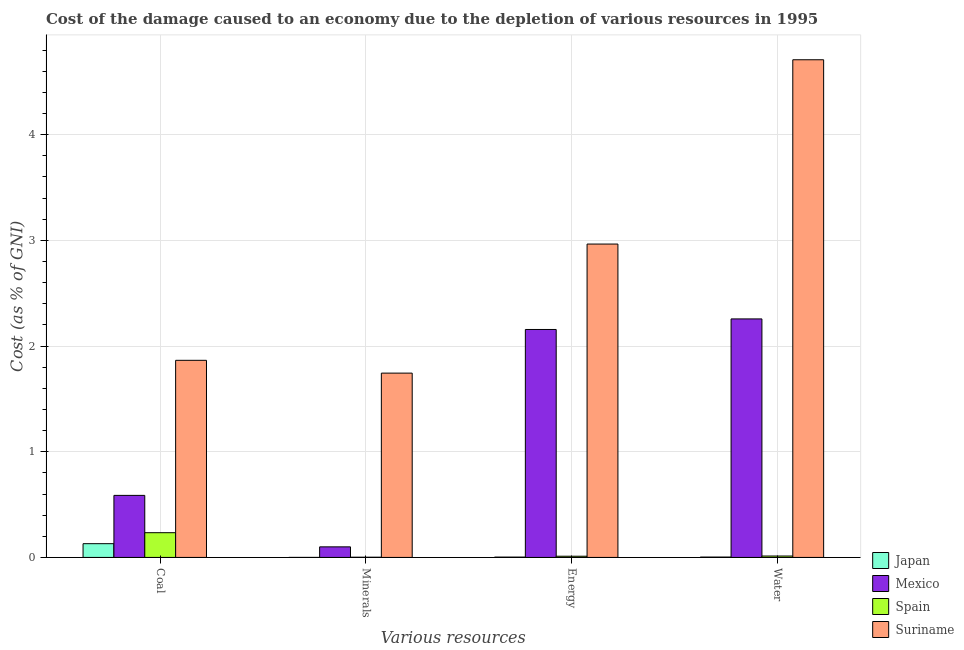How many bars are there on the 4th tick from the left?
Give a very brief answer. 4. What is the label of the 4th group of bars from the left?
Your response must be concise. Water. What is the cost of damage due to depletion of water in Suriname?
Offer a very short reply. 4.71. Across all countries, what is the maximum cost of damage due to depletion of water?
Your answer should be compact. 4.71. Across all countries, what is the minimum cost of damage due to depletion of water?
Offer a terse response. 0. In which country was the cost of damage due to depletion of coal maximum?
Your answer should be very brief. Suriname. In which country was the cost of damage due to depletion of coal minimum?
Keep it short and to the point. Japan. What is the total cost of damage due to depletion of coal in the graph?
Your response must be concise. 2.82. What is the difference between the cost of damage due to depletion of water in Suriname and that in Japan?
Your answer should be very brief. 4.71. What is the difference between the cost of damage due to depletion of water in Japan and the cost of damage due to depletion of minerals in Mexico?
Make the answer very short. -0.1. What is the average cost of damage due to depletion of energy per country?
Provide a short and direct response. 1.28. What is the difference between the cost of damage due to depletion of coal and cost of damage due to depletion of water in Suriname?
Keep it short and to the point. -2.84. In how many countries, is the cost of damage due to depletion of water greater than 0.2 %?
Offer a terse response. 2. What is the ratio of the cost of damage due to depletion of water in Spain to that in Suriname?
Make the answer very short. 0. Is the cost of damage due to depletion of energy in Suriname less than that in Japan?
Offer a terse response. No. What is the difference between the highest and the second highest cost of damage due to depletion of energy?
Your response must be concise. 0.81. What is the difference between the highest and the lowest cost of damage due to depletion of coal?
Offer a very short reply. 1.73. In how many countries, is the cost of damage due to depletion of energy greater than the average cost of damage due to depletion of energy taken over all countries?
Offer a terse response. 2. What does the 1st bar from the left in Energy represents?
Offer a terse response. Japan. What does the 3rd bar from the right in Coal represents?
Your answer should be compact. Mexico. Are all the bars in the graph horizontal?
Offer a very short reply. No. Where does the legend appear in the graph?
Offer a terse response. Bottom right. How many legend labels are there?
Provide a short and direct response. 4. What is the title of the graph?
Keep it short and to the point. Cost of the damage caused to an economy due to the depletion of various resources in 1995 . What is the label or title of the X-axis?
Your answer should be very brief. Various resources. What is the label or title of the Y-axis?
Your answer should be very brief. Cost (as % of GNI). What is the Cost (as % of GNI) of Japan in Coal?
Provide a short and direct response. 0.13. What is the Cost (as % of GNI) in Mexico in Coal?
Your response must be concise. 0.59. What is the Cost (as % of GNI) in Spain in Coal?
Offer a very short reply. 0.23. What is the Cost (as % of GNI) in Suriname in Coal?
Your answer should be very brief. 1.86. What is the Cost (as % of GNI) of Japan in Minerals?
Provide a short and direct response. 0. What is the Cost (as % of GNI) of Mexico in Minerals?
Give a very brief answer. 0.1. What is the Cost (as % of GNI) of Spain in Minerals?
Your answer should be very brief. 0. What is the Cost (as % of GNI) of Suriname in Minerals?
Provide a succinct answer. 1.74. What is the Cost (as % of GNI) in Japan in Energy?
Your answer should be compact. 0. What is the Cost (as % of GNI) of Mexico in Energy?
Offer a very short reply. 2.16. What is the Cost (as % of GNI) of Spain in Energy?
Your response must be concise. 0.01. What is the Cost (as % of GNI) of Suriname in Energy?
Keep it short and to the point. 2.97. What is the Cost (as % of GNI) of Japan in Water?
Give a very brief answer. 0. What is the Cost (as % of GNI) in Mexico in Water?
Offer a very short reply. 2.26. What is the Cost (as % of GNI) of Spain in Water?
Give a very brief answer. 0.01. What is the Cost (as % of GNI) in Suriname in Water?
Ensure brevity in your answer.  4.71. Across all Various resources, what is the maximum Cost (as % of GNI) of Japan?
Provide a short and direct response. 0.13. Across all Various resources, what is the maximum Cost (as % of GNI) of Mexico?
Your answer should be very brief. 2.26. Across all Various resources, what is the maximum Cost (as % of GNI) in Spain?
Provide a succinct answer. 0.23. Across all Various resources, what is the maximum Cost (as % of GNI) in Suriname?
Your response must be concise. 4.71. Across all Various resources, what is the minimum Cost (as % of GNI) in Japan?
Make the answer very short. 0. Across all Various resources, what is the minimum Cost (as % of GNI) in Mexico?
Give a very brief answer. 0.1. Across all Various resources, what is the minimum Cost (as % of GNI) in Spain?
Give a very brief answer. 0. Across all Various resources, what is the minimum Cost (as % of GNI) in Suriname?
Keep it short and to the point. 1.74. What is the total Cost (as % of GNI) of Japan in the graph?
Your response must be concise. 0.14. What is the total Cost (as % of GNI) in Mexico in the graph?
Offer a terse response. 5.1. What is the total Cost (as % of GNI) of Spain in the graph?
Ensure brevity in your answer.  0.26. What is the total Cost (as % of GNI) of Suriname in the graph?
Give a very brief answer. 11.28. What is the difference between the Cost (as % of GNI) of Japan in Coal and that in Minerals?
Give a very brief answer. 0.13. What is the difference between the Cost (as % of GNI) of Mexico in Coal and that in Minerals?
Provide a short and direct response. 0.49. What is the difference between the Cost (as % of GNI) in Spain in Coal and that in Minerals?
Give a very brief answer. 0.23. What is the difference between the Cost (as % of GNI) in Suriname in Coal and that in Minerals?
Provide a succinct answer. 0.12. What is the difference between the Cost (as % of GNI) in Japan in Coal and that in Energy?
Your response must be concise. 0.13. What is the difference between the Cost (as % of GNI) in Mexico in Coal and that in Energy?
Ensure brevity in your answer.  -1.57. What is the difference between the Cost (as % of GNI) in Spain in Coal and that in Energy?
Provide a short and direct response. 0.22. What is the difference between the Cost (as % of GNI) of Suriname in Coal and that in Energy?
Your response must be concise. -1.1. What is the difference between the Cost (as % of GNI) of Japan in Coal and that in Water?
Your answer should be very brief. 0.13. What is the difference between the Cost (as % of GNI) of Mexico in Coal and that in Water?
Offer a terse response. -1.67. What is the difference between the Cost (as % of GNI) in Spain in Coal and that in Water?
Offer a terse response. 0.22. What is the difference between the Cost (as % of GNI) of Suriname in Coal and that in Water?
Your answer should be compact. -2.84. What is the difference between the Cost (as % of GNI) in Japan in Minerals and that in Energy?
Make the answer very short. -0. What is the difference between the Cost (as % of GNI) in Mexico in Minerals and that in Energy?
Provide a succinct answer. -2.06. What is the difference between the Cost (as % of GNI) of Spain in Minerals and that in Energy?
Make the answer very short. -0.01. What is the difference between the Cost (as % of GNI) of Suriname in Minerals and that in Energy?
Your answer should be compact. -1.22. What is the difference between the Cost (as % of GNI) in Japan in Minerals and that in Water?
Offer a terse response. -0. What is the difference between the Cost (as % of GNI) of Mexico in Minerals and that in Water?
Offer a terse response. -2.16. What is the difference between the Cost (as % of GNI) of Spain in Minerals and that in Water?
Your response must be concise. -0.01. What is the difference between the Cost (as % of GNI) in Suriname in Minerals and that in Water?
Offer a very short reply. -2.96. What is the difference between the Cost (as % of GNI) in Japan in Energy and that in Water?
Provide a short and direct response. -0. What is the difference between the Cost (as % of GNI) of Mexico in Energy and that in Water?
Provide a short and direct response. -0.1. What is the difference between the Cost (as % of GNI) of Spain in Energy and that in Water?
Offer a very short reply. -0. What is the difference between the Cost (as % of GNI) in Suriname in Energy and that in Water?
Offer a terse response. -1.74. What is the difference between the Cost (as % of GNI) of Japan in Coal and the Cost (as % of GNI) of Mexico in Minerals?
Offer a terse response. 0.03. What is the difference between the Cost (as % of GNI) in Japan in Coal and the Cost (as % of GNI) in Spain in Minerals?
Your answer should be very brief. 0.13. What is the difference between the Cost (as % of GNI) in Japan in Coal and the Cost (as % of GNI) in Suriname in Minerals?
Provide a short and direct response. -1.61. What is the difference between the Cost (as % of GNI) of Mexico in Coal and the Cost (as % of GNI) of Spain in Minerals?
Offer a very short reply. 0.59. What is the difference between the Cost (as % of GNI) of Mexico in Coal and the Cost (as % of GNI) of Suriname in Minerals?
Keep it short and to the point. -1.16. What is the difference between the Cost (as % of GNI) of Spain in Coal and the Cost (as % of GNI) of Suriname in Minerals?
Provide a short and direct response. -1.51. What is the difference between the Cost (as % of GNI) in Japan in Coal and the Cost (as % of GNI) in Mexico in Energy?
Keep it short and to the point. -2.03. What is the difference between the Cost (as % of GNI) of Japan in Coal and the Cost (as % of GNI) of Spain in Energy?
Keep it short and to the point. 0.12. What is the difference between the Cost (as % of GNI) of Japan in Coal and the Cost (as % of GNI) of Suriname in Energy?
Ensure brevity in your answer.  -2.83. What is the difference between the Cost (as % of GNI) of Mexico in Coal and the Cost (as % of GNI) of Spain in Energy?
Keep it short and to the point. 0.58. What is the difference between the Cost (as % of GNI) of Mexico in Coal and the Cost (as % of GNI) of Suriname in Energy?
Offer a terse response. -2.38. What is the difference between the Cost (as % of GNI) in Spain in Coal and the Cost (as % of GNI) in Suriname in Energy?
Offer a very short reply. -2.73. What is the difference between the Cost (as % of GNI) in Japan in Coal and the Cost (as % of GNI) in Mexico in Water?
Offer a terse response. -2.13. What is the difference between the Cost (as % of GNI) in Japan in Coal and the Cost (as % of GNI) in Spain in Water?
Your response must be concise. 0.12. What is the difference between the Cost (as % of GNI) of Japan in Coal and the Cost (as % of GNI) of Suriname in Water?
Give a very brief answer. -4.58. What is the difference between the Cost (as % of GNI) of Mexico in Coal and the Cost (as % of GNI) of Spain in Water?
Give a very brief answer. 0.57. What is the difference between the Cost (as % of GNI) in Mexico in Coal and the Cost (as % of GNI) in Suriname in Water?
Make the answer very short. -4.12. What is the difference between the Cost (as % of GNI) of Spain in Coal and the Cost (as % of GNI) of Suriname in Water?
Your answer should be very brief. -4.47. What is the difference between the Cost (as % of GNI) in Japan in Minerals and the Cost (as % of GNI) in Mexico in Energy?
Offer a very short reply. -2.16. What is the difference between the Cost (as % of GNI) of Japan in Minerals and the Cost (as % of GNI) of Spain in Energy?
Provide a short and direct response. -0.01. What is the difference between the Cost (as % of GNI) of Japan in Minerals and the Cost (as % of GNI) of Suriname in Energy?
Offer a very short reply. -2.96. What is the difference between the Cost (as % of GNI) in Mexico in Minerals and the Cost (as % of GNI) in Spain in Energy?
Your answer should be compact. 0.09. What is the difference between the Cost (as % of GNI) in Mexico in Minerals and the Cost (as % of GNI) in Suriname in Energy?
Offer a very short reply. -2.87. What is the difference between the Cost (as % of GNI) of Spain in Minerals and the Cost (as % of GNI) of Suriname in Energy?
Give a very brief answer. -2.96. What is the difference between the Cost (as % of GNI) in Japan in Minerals and the Cost (as % of GNI) in Mexico in Water?
Your answer should be very brief. -2.26. What is the difference between the Cost (as % of GNI) of Japan in Minerals and the Cost (as % of GNI) of Spain in Water?
Your answer should be very brief. -0.01. What is the difference between the Cost (as % of GNI) of Japan in Minerals and the Cost (as % of GNI) of Suriname in Water?
Make the answer very short. -4.71. What is the difference between the Cost (as % of GNI) in Mexico in Minerals and the Cost (as % of GNI) in Spain in Water?
Offer a very short reply. 0.09. What is the difference between the Cost (as % of GNI) in Mexico in Minerals and the Cost (as % of GNI) in Suriname in Water?
Offer a terse response. -4.61. What is the difference between the Cost (as % of GNI) in Spain in Minerals and the Cost (as % of GNI) in Suriname in Water?
Provide a short and direct response. -4.71. What is the difference between the Cost (as % of GNI) of Japan in Energy and the Cost (as % of GNI) of Mexico in Water?
Ensure brevity in your answer.  -2.25. What is the difference between the Cost (as % of GNI) in Japan in Energy and the Cost (as % of GNI) in Spain in Water?
Provide a short and direct response. -0.01. What is the difference between the Cost (as % of GNI) in Japan in Energy and the Cost (as % of GNI) in Suriname in Water?
Your answer should be very brief. -4.71. What is the difference between the Cost (as % of GNI) in Mexico in Energy and the Cost (as % of GNI) in Spain in Water?
Make the answer very short. 2.14. What is the difference between the Cost (as % of GNI) in Mexico in Energy and the Cost (as % of GNI) in Suriname in Water?
Ensure brevity in your answer.  -2.55. What is the difference between the Cost (as % of GNI) of Spain in Energy and the Cost (as % of GNI) of Suriname in Water?
Offer a terse response. -4.7. What is the average Cost (as % of GNI) of Japan per Various resources?
Ensure brevity in your answer.  0.03. What is the average Cost (as % of GNI) of Mexico per Various resources?
Make the answer very short. 1.28. What is the average Cost (as % of GNI) in Spain per Various resources?
Your response must be concise. 0.07. What is the average Cost (as % of GNI) in Suriname per Various resources?
Keep it short and to the point. 2.82. What is the difference between the Cost (as % of GNI) of Japan and Cost (as % of GNI) of Mexico in Coal?
Offer a very short reply. -0.46. What is the difference between the Cost (as % of GNI) in Japan and Cost (as % of GNI) in Spain in Coal?
Keep it short and to the point. -0.1. What is the difference between the Cost (as % of GNI) in Japan and Cost (as % of GNI) in Suriname in Coal?
Your answer should be compact. -1.73. What is the difference between the Cost (as % of GNI) in Mexico and Cost (as % of GNI) in Spain in Coal?
Make the answer very short. 0.35. What is the difference between the Cost (as % of GNI) in Mexico and Cost (as % of GNI) in Suriname in Coal?
Ensure brevity in your answer.  -1.28. What is the difference between the Cost (as % of GNI) in Spain and Cost (as % of GNI) in Suriname in Coal?
Ensure brevity in your answer.  -1.63. What is the difference between the Cost (as % of GNI) in Japan and Cost (as % of GNI) in Mexico in Minerals?
Your response must be concise. -0.1. What is the difference between the Cost (as % of GNI) of Japan and Cost (as % of GNI) of Spain in Minerals?
Your answer should be very brief. -0. What is the difference between the Cost (as % of GNI) in Japan and Cost (as % of GNI) in Suriname in Minerals?
Your answer should be compact. -1.74. What is the difference between the Cost (as % of GNI) of Mexico and Cost (as % of GNI) of Spain in Minerals?
Your response must be concise. 0.1. What is the difference between the Cost (as % of GNI) of Mexico and Cost (as % of GNI) of Suriname in Minerals?
Your response must be concise. -1.64. What is the difference between the Cost (as % of GNI) of Spain and Cost (as % of GNI) of Suriname in Minerals?
Your answer should be very brief. -1.74. What is the difference between the Cost (as % of GNI) of Japan and Cost (as % of GNI) of Mexico in Energy?
Keep it short and to the point. -2.15. What is the difference between the Cost (as % of GNI) of Japan and Cost (as % of GNI) of Spain in Energy?
Offer a terse response. -0.01. What is the difference between the Cost (as % of GNI) in Japan and Cost (as % of GNI) in Suriname in Energy?
Give a very brief answer. -2.96. What is the difference between the Cost (as % of GNI) in Mexico and Cost (as % of GNI) in Spain in Energy?
Keep it short and to the point. 2.15. What is the difference between the Cost (as % of GNI) of Mexico and Cost (as % of GNI) of Suriname in Energy?
Your response must be concise. -0.81. What is the difference between the Cost (as % of GNI) of Spain and Cost (as % of GNI) of Suriname in Energy?
Provide a short and direct response. -2.95. What is the difference between the Cost (as % of GNI) in Japan and Cost (as % of GNI) in Mexico in Water?
Your answer should be very brief. -2.25. What is the difference between the Cost (as % of GNI) of Japan and Cost (as % of GNI) of Spain in Water?
Provide a short and direct response. -0.01. What is the difference between the Cost (as % of GNI) of Japan and Cost (as % of GNI) of Suriname in Water?
Offer a terse response. -4.71. What is the difference between the Cost (as % of GNI) of Mexico and Cost (as % of GNI) of Spain in Water?
Your response must be concise. 2.24. What is the difference between the Cost (as % of GNI) in Mexico and Cost (as % of GNI) in Suriname in Water?
Ensure brevity in your answer.  -2.45. What is the difference between the Cost (as % of GNI) in Spain and Cost (as % of GNI) in Suriname in Water?
Provide a short and direct response. -4.7. What is the ratio of the Cost (as % of GNI) in Japan in Coal to that in Minerals?
Your response must be concise. 722.96. What is the ratio of the Cost (as % of GNI) in Mexico in Coal to that in Minerals?
Your response must be concise. 5.87. What is the ratio of the Cost (as % of GNI) in Spain in Coal to that in Minerals?
Offer a very short reply. 127.5. What is the ratio of the Cost (as % of GNI) of Suriname in Coal to that in Minerals?
Offer a terse response. 1.07. What is the ratio of the Cost (as % of GNI) of Japan in Coal to that in Energy?
Ensure brevity in your answer.  41.8. What is the ratio of the Cost (as % of GNI) in Mexico in Coal to that in Energy?
Ensure brevity in your answer.  0.27. What is the ratio of the Cost (as % of GNI) of Spain in Coal to that in Energy?
Make the answer very short. 20.49. What is the ratio of the Cost (as % of GNI) of Suriname in Coal to that in Energy?
Provide a succinct answer. 0.63. What is the ratio of the Cost (as % of GNI) in Japan in Coal to that in Water?
Provide a short and direct response. 39.51. What is the ratio of the Cost (as % of GNI) in Mexico in Coal to that in Water?
Offer a terse response. 0.26. What is the ratio of the Cost (as % of GNI) in Spain in Coal to that in Water?
Keep it short and to the point. 17.66. What is the ratio of the Cost (as % of GNI) in Suriname in Coal to that in Water?
Ensure brevity in your answer.  0.4. What is the ratio of the Cost (as % of GNI) of Japan in Minerals to that in Energy?
Give a very brief answer. 0.06. What is the ratio of the Cost (as % of GNI) of Mexico in Minerals to that in Energy?
Offer a very short reply. 0.05. What is the ratio of the Cost (as % of GNI) of Spain in Minerals to that in Energy?
Ensure brevity in your answer.  0.16. What is the ratio of the Cost (as % of GNI) of Suriname in Minerals to that in Energy?
Keep it short and to the point. 0.59. What is the ratio of the Cost (as % of GNI) in Japan in Minerals to that in Water?
Provide a short and direct response. 0.05. What is the ratio of the Cost (as % of GNI) in Mexico in Minerals to that in Water?
Ensure brevity in your answer.  0.04. What is the ratio of the Cost (as % of GNI) of Spain in Minerals to that in Water?
Your response must be concise. 0.14. What is the ratio of the Cost (as % of GNI) in Suriname in Minerals to that in Water?
Your answer should be very brief. 0.37. What is the ratio of the Cost (as % of GNI) of Japan in Energy to that in Water?
Ensure brevity in your answer.  0.95. What is the ratio of the Cost (as % of GNI) of Mexico in Energy to that in Water?
Your answer should be very brief. 0.96. What is the ratio of the Cost (as % of GNI) of Spain in Energy to that in Water?
Ensure brevity in your answer.  0.86. What is the ratio of the Cost (as % of GNI) in Suriname in Energy to that in Water?
Make the answer very short. 0.63. What is the difference between the highest and the second highest Cost (as % of GNI) in Japan?
Your answer should be very brief. 0.13. What is the difference between the highest and the second highest Cost (as % of GNI) of Mexico?
Offer a terse response. 0.1. What is the difference between the highest and the second highest Cost (as % of GNI) of Spain?
Ensure brevity in your answer.  0.22. What is the difference between the highest and the second highest Cost (as % of GNI) of Suriname?
Make the answer very short. 1.74. What is the difference between the highest and the lowest Cost (as % of GNI) in Japan?
Make the answer very short. 0.13. What is the difference between the highest and the lowest Cost (as % of GNI) in Mexico?
Your answer should be compact. 2.16. What is the difference between the highest and the lowest Cost (as % of GNI) in Spain?
Offer a terse response. 0.23. What is the difference between the highest and the lowest Cost (as % of GNI) of Suriname?
Offer a very short reply. 2.96. 